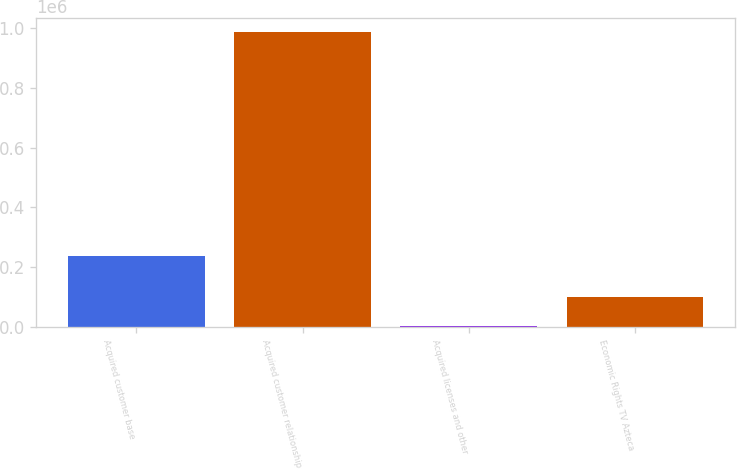<chart> <loc_0><loc_0><loc_500><loc_500><bar_chart><fcel>Acquired customer base<fcel>Acquired customer relationship<fcel>Acquired licenses and other<fcel>Economic Rights TV Azteca<nl><fcel>236881<fcel>985664<fcel>1617<fcel>100022<nl></chart> 